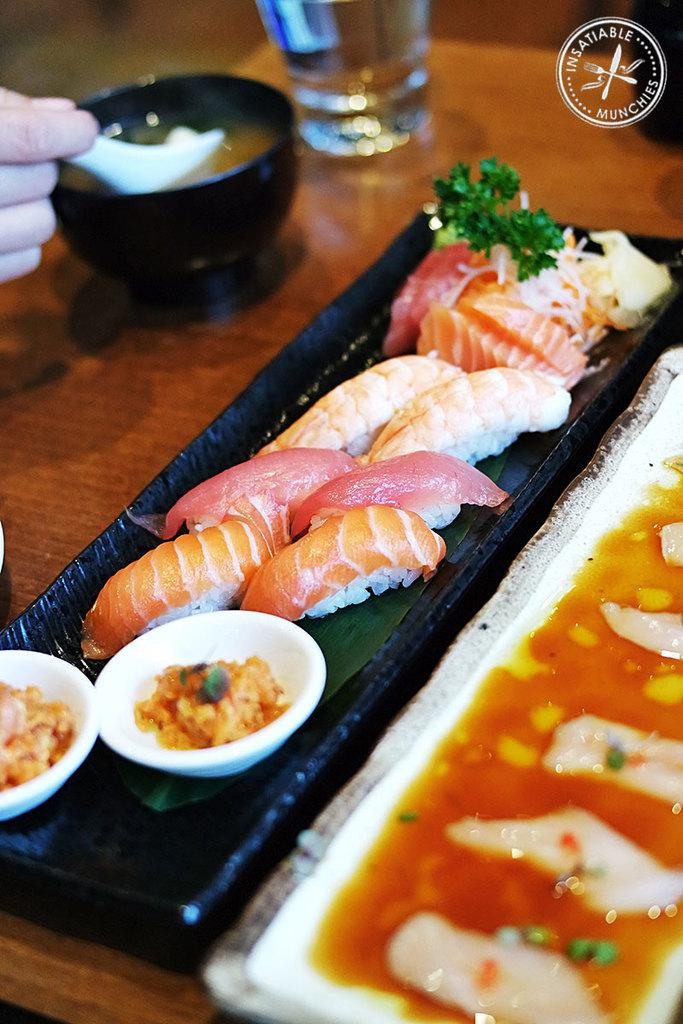What type of containers are holding food in the image? There are plates and bowls holding food in the image. What else can be seen on the table in the image? There is a glass on the table in the image. How many feathers can be seen on the robin in the image? There is no robin present in the image; it only features food in plates, bowls, and a glass on the table. 